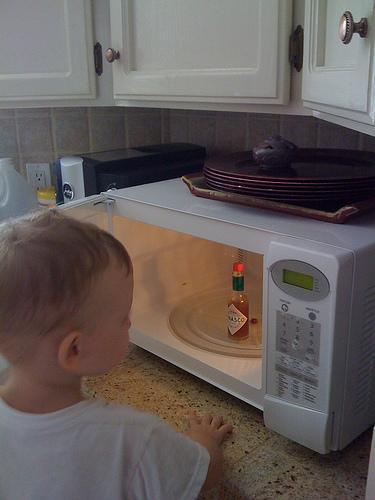How many people are in the photo?
Give a very brief answer. 1. 